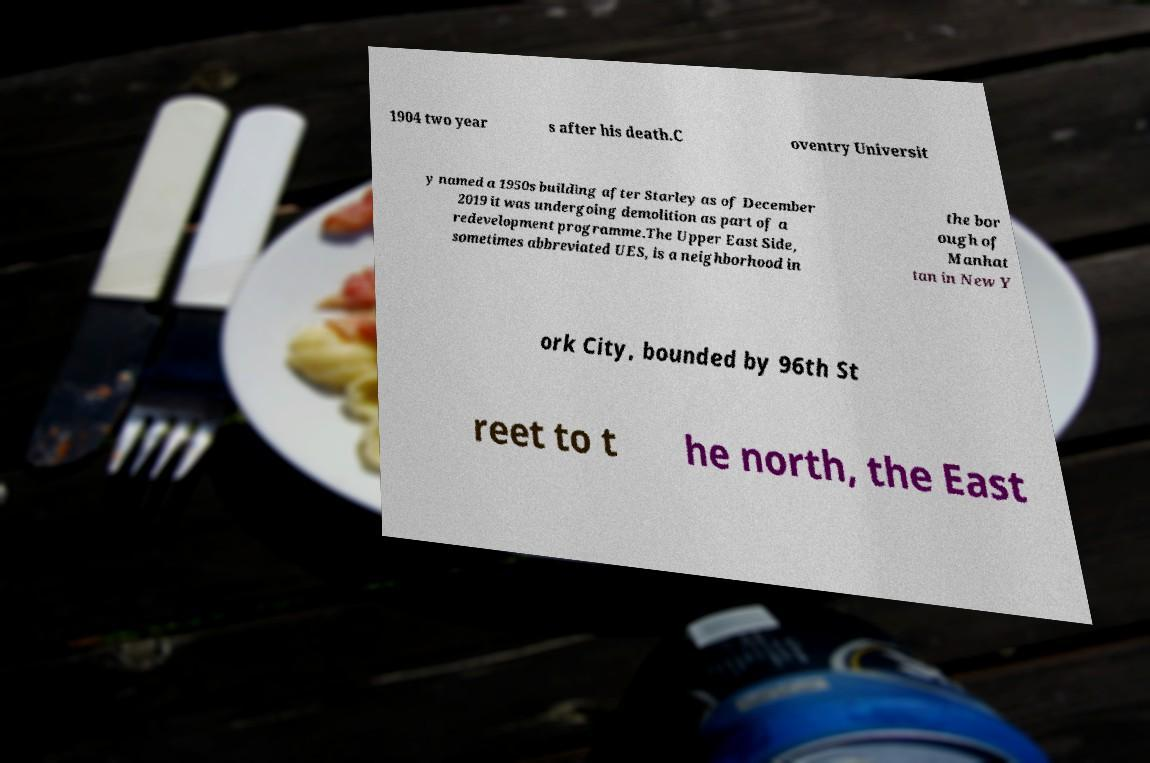Please identify and transcribe the text found in this image. 1904 two year s after his death.C oventry Universit y named a 1950s building after Starley as of December 2019 it was undergoing demolition as part of a redevelopment programme.The Upper East Side, sometimes abbreviated UES, is a neighborhood in the bor ough of Manhat tan in New Y ork City, bounded by 96th St reet to t he north, the East 